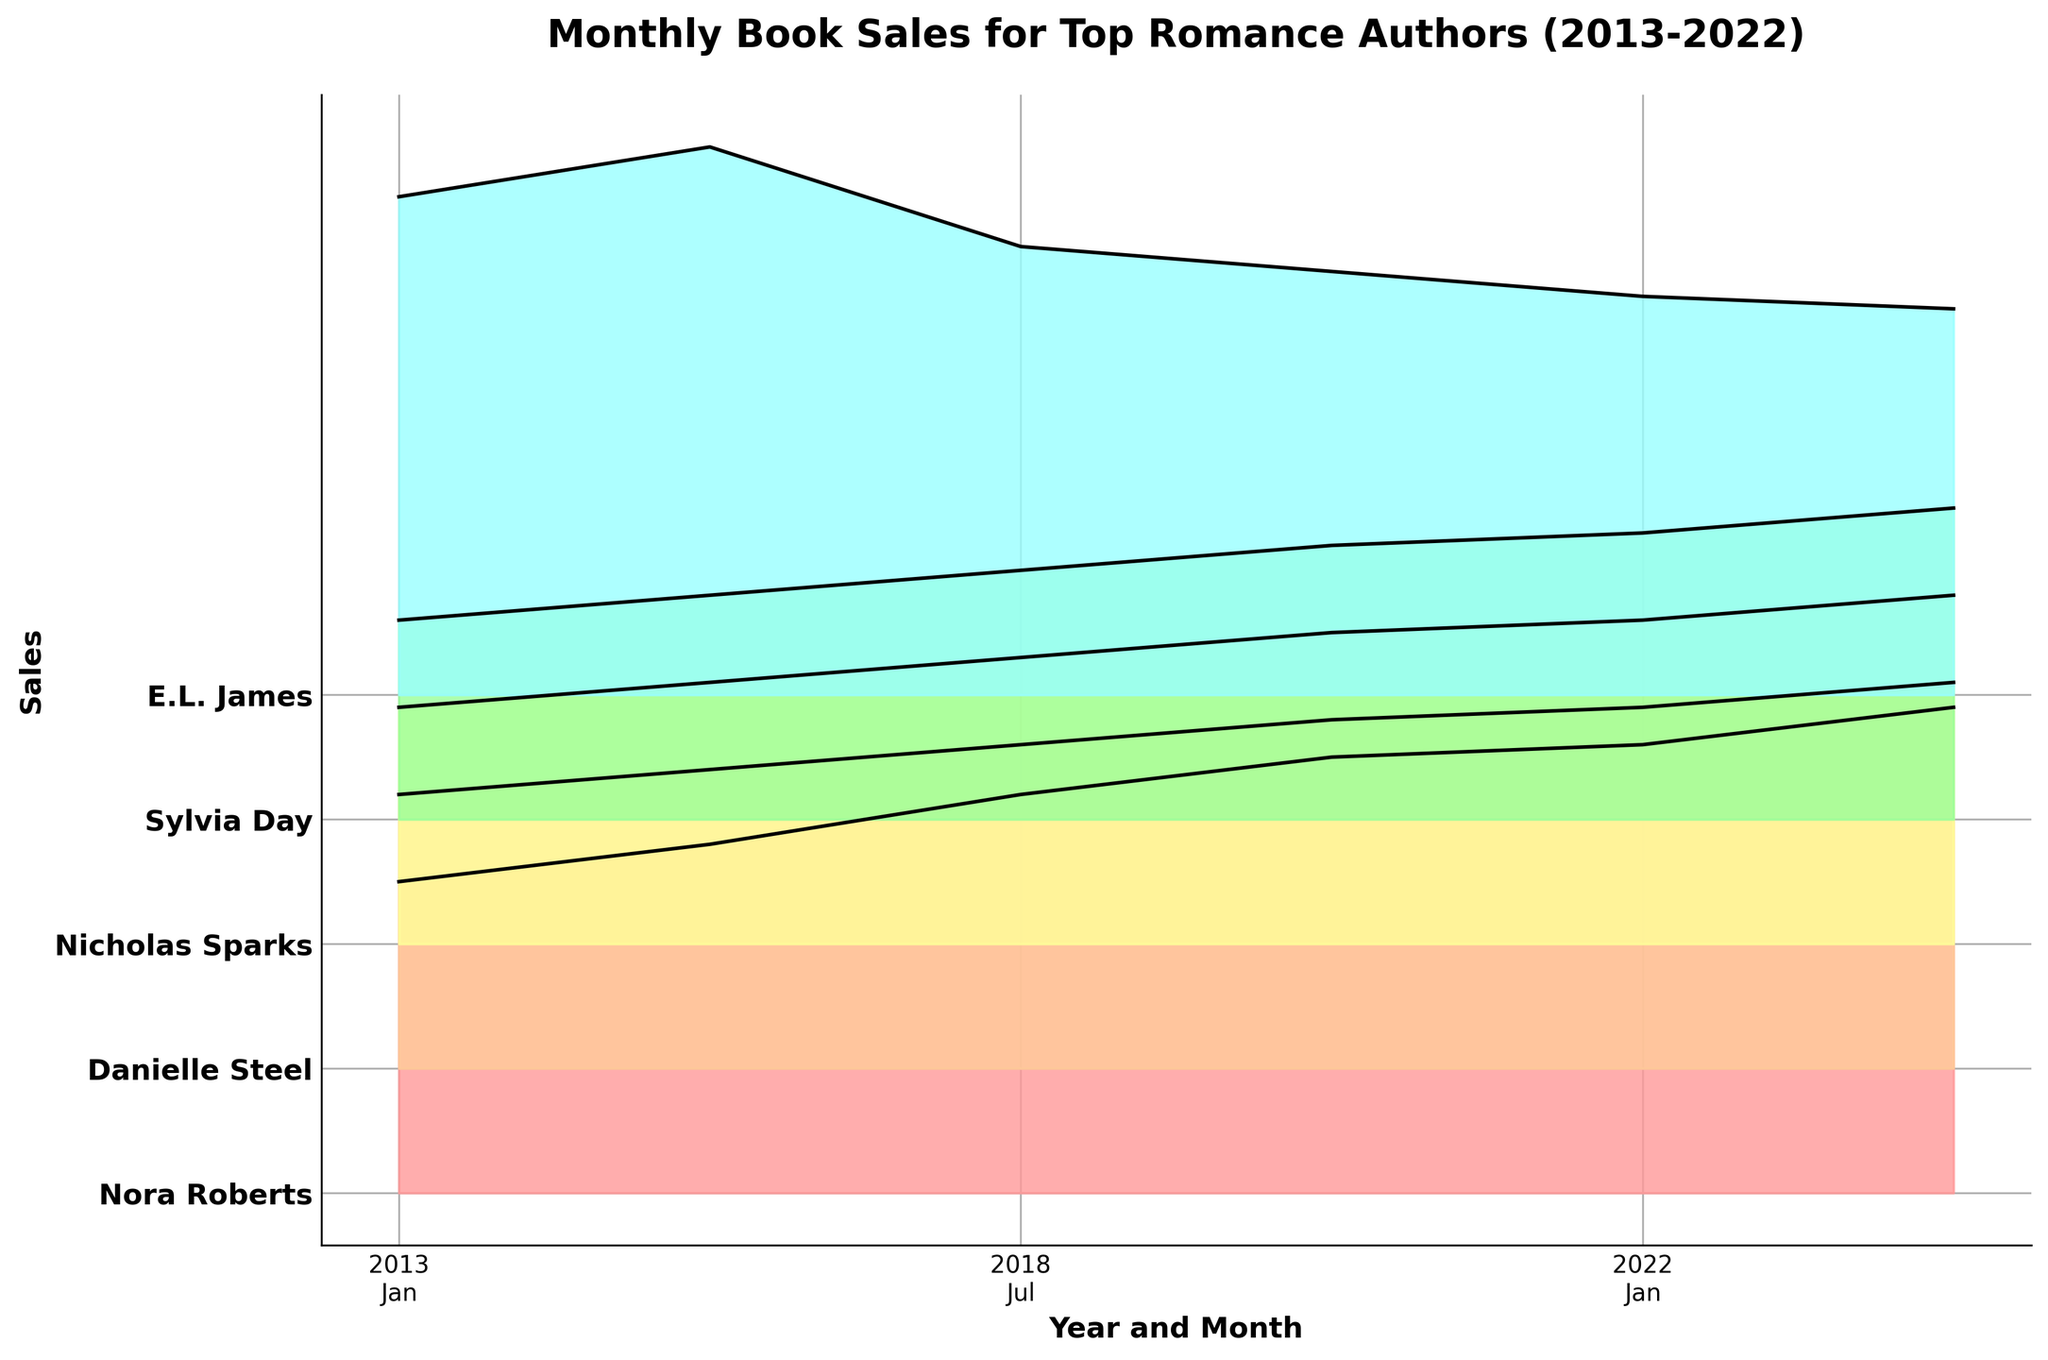How many authors' sales are plotted in the figure? There are five distinct ridgelines, each corresponding to a different author, representing their monthly sales data.
Answer: 5 What time period does the plot cover? The x-axis labels indicate the data covers the years 2013, 2018, and 2022, with monthly sales in January and July of each year.
Answer: 2013-2022 Which author had the highest sales in January 2013? By looking at the plot, E.L. James's ridgeline is the highest among all authors for January 2013.
Answer: E.L. James What is the trend of Nora Roberts' sales from 2013 to 2022? Nora Roberts' sales show an increasing trend from 125,000 in January 2013 to 195,000 in July 2022 as observed from her ridgeline on the plot.
Answer: Increasing Compare the sales figures of Sylvia Day in July 2013 and July 2022. Sylvia Day's sales increased from 90,000 in July 2013 to 125,000 in July 2022, as seen by the rise on her ridgeline from one point to the other.
Answer: Increased How do Danielle Steel's sales in January 2022 compare to those in January 2013? Danielle Steel's sales have risen from 110,000 in January 2013 to 145,000 in January 2022, as indicated by a higher position on the plot.
Answer: Increased Which author showed a decrease in sales between January 2013 and January 2022? E.L. James' ridgeline shows a decrease in sales from 200,000 in January 2013 to 160,000 in January 2022.
Answer: E.L. James What is the relative position of Nicholas Sparks' sales in July 2018 compared to the other authors? Nicholas Sparks' sales in July 2018 are positioned around the middle of the plot, higher than Sylvia Day, but lower than E.L. James, Nora Roberts, and Danielle Steel.
Answer: Middle Which author had the closest sales figures in both January and July of 2022? E.L. James' sales were 160,000 in January and 155,000 in July 2022, showing the smallest difference as seen by the close positions on the ridgeline.
Answer: E.L. James Examine Sylvia Day’s sales trend between January to July in each year covered. In 2013, Sylvia Day's sales increased from 80,000 to 90,000. In 2018, they increased from 100,000 to 110,000. In 2022, they increased from 115,000 to 125,000. Thus, there is a small but consistent increase in each year.
Answer: Increasing 